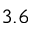Convert formula to latex. <formula><loc_0><loc_0><loc_500><loc_500>3 . 6</formula> 